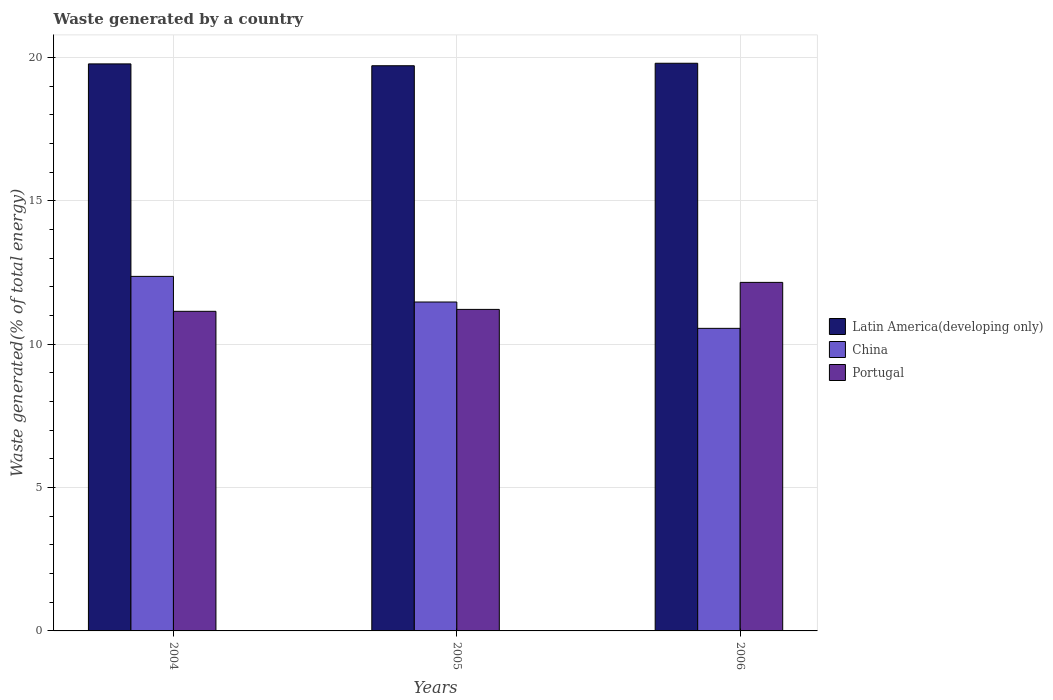Are the number of bars per tick equal to the number of legend labels?
Ensure brevity in your answer.  Yes. How many bars are there on the 2nd tick from the right?
Give a very brief answer. 3. What is the label of the 1st group of bars from the left?
Your answer should be compact. 2004. In how many cases, is the number of bars for a given year not equal to the number of legend labels?
Give a very brief answer. 0. What is the total waste generated in China in 2005?
Offer a terse response. 11.47. Across all years, what is the maximum total waste generated in Latin America(developing only)?
Ensure brevity in your answer.  19.79. Across all years, what is the minimum total waste generated in China?
Make the answer very short. 10.55. In which year was the total waste generated in Latin America(developing only) maximum?
Offer a terse response. 2006. What is the total total waste generated in Latin America(developing only) in the graph?
Provide a succinct answer. 59.28. What is the difference between the total waste generated in Portugal in 2005 and that in 2006?
Your response must be concise. -0.94. What is the difference between the total waste generated in Portugal in 2006 and the total waste generated in China in 2004?
Keep it short and to the point. -0.21. What is the average total waste generated in Portugal per year?
Your response must be concise. 11.5. In the year 2006, what is the difference between the total waste generated in Latin America(developing only) and total waste generated in Portugal?
Your answer should be very brief. 7.64. What is the ratio of the total waste generated in China in 2004 to that in 2005?
Provide a short and direct response. 1.08. Is the difference between the total waste generated in Latin America(developing only) in 2004 and 2006 greater than the difference between the total waste generated in Portugal in 2004 and 2006?
Offer a terse response. Yes. What is the difference between the highest and the second highest total waste generated in Latin America(developing only)?
Provide a succinct answer. 0.02. What is the difference between the highest and the lowest total waste generated in Portugal?
Offer a terse response. 1.01. In how many years, is the total waste generated in China greater than the average total waste generated in China taken over all years?
Provide a short and direct response. 2. Is the sum of the total waste generated in Latin America(developing only) in 2004 and 2005 greater than the maximum total waste generated in China across all years?
Offer a terse response. Yes. What does the 1st bar from the left in 2006 represents?
Your answer should be compact. Latin America(developing only). What does the 1st bar from the right in 2005 represents?
Offer a terse response. Portugal. Is it the case that in every year, the sum of the total waste generated in China and total waste generated in Portugal is greater than the total waste generated in Latin America(developing only)?
Your answer should be very brief. Yes. What is the difference between two consecutive major ticks on the Y-axis?
Make the answer very short. 5. Does the graph contain any zero values?
Provide a succinct answer. No. Does the graph contain grids?
Offer a terse response. Yes. Where does the legend appear in the graph?
Ensure brevity in your answer.  Center right. How many legend labels are there?
Keep it short and to the point. 3. How are the legend labels stacked?
Offer a terse response. Vertical. What is the title of the graph?
Provide a succinct answer. Waste generated by a country. What is the label or title of the X-axis?
Make the answer very short. Years. What is the label or title of the Y-axis?
Ensure brevity in your answer.  Waste generated(% of total energy). What is the Waste generated(% of total energy) in Latin America(developing only) in 2004?
Your response must be concise. 19.77. What is the Waste generated(% of total energy) in China in 2004?
Offer a very short reply. 12.36. What is the Waste generated(% of total energy) in Portugal in 2004?
Provide a short and direct response. 11.14. What is the Waste generated(% of total energy) of Latin America(developing only) in 2005?
Your response must be concise. 19.71. What is the Waste generated(% of total energy) of China in 2005?
Provide a succinct answer. 11.47. What is the Waste generated(% of total energy) of Portugal in 2005?
Offer a very short reply. 11.21. What is the Waste generated(% of total energy) of Latin America(developing only) in 2006?
Provide a succinct answer. 19.79. What is the Waste generated(% of total energy) in China in 2006?
Make the answer very short. 10.55. What is the Waste generated(% of total energy) in Portugal in 2006?
Keep it short and to the point. 12.15. Across all years, what is the maximum Waste generated(% of total energy) of Latin America(developing only)?
Your answer should be very brief. 19.79. Across all years, what is the maximum Waste generated(% of total energy) in China?
Offer a very short reply. 12.36. Across all years, what is the maximum Waste generated(% of total energy) of Portugal?
Provide a succinct answer. 12.15. Across all years, what is the minimum Waste generated(% of total energy) in Latin America(developing only)?
Make the answer very short. 19.71. Across all years, what is the minimum Waste generated(% of total energy) in China?
Your response must be concise. 10.55. Across all years, what is the minimum Waste generated(% of total energy) in Portugal?
Your answer should be compact. 11.14. What is the total Waste generated(% of total energy) of Latin America(developing only) in the graph?
Provide a succinct answer. 59.28. What is the total Waste generated(% of total energy) of China in the graph?
Offer a very short reply. 34.38. What is the total Waste generated(% of total energy) of Portugal in the graph?
Ensure brevity in your answer.  34.51. What is the difference between the Waste generated(% of total energy) in Latin America(developing only) in 2004 and that in 2005?
Make the answer very short. 0.06. What is the difference between the Waste generated(% of total energy) in China in 2004 and that in 2005?
Your response must be concise. 0.89. What is the difference between the Waste generated(% of total energy) in Portugal in 2004 and that in 2005?
Provide a succinct answer. -0.07. What is the difference between the Waste generated(% of total energy) of Latin America(developing only) in 2004 and that in 2006?
Offer a terse response. -0.02. What is the difference between the Waste generated(% of total energy) of China in 2004 and that in 2006?
Provide a succinct answer. 1.81. What is the difference between the Waste generated(% of total energy) in Portugal in 2004 and that in 2006?
Provide a short and direct response. -1.01. What is the difference between the Waste generated(% of total energy) of Latin America(developing only) in 2005 and that in 2006?
Provide a short and direct response. -0.09. What is the difference between the Waste generated(% of total energy) in China in 2005 and that in 2006?
Your answer should be very brief. 0.92. What is the difference between the Waste generated(% of total energy) in Portugal in 2005 and that in 2006?
Provide a succinct answer. -0.94. What is the difference between the Waste generated(% of total energy) in Latin America(developing only) in 2004 and the Waste generated(% of total energy) in China in 2005?
Offer a very short reply. 8.3. What is the difference between the Waste generated(% of total energy) in Latin America(developing only) in 2004 and the Waste generated(% of total energy) in Portugal in 2005?
Your answer should be very brief. 8.56. What is the difference between the Waste generated(% of total energy) of China in 2004 and the Waste generated(% of total energy) of Portugal in 2005?
Offer a very short reply. 1.15. What is the difference between the Waste generated(% of total energy) in Latin America(developing only) in 2004 and the Waste generated(% of total energy) in China in 2006?
Your answer should be very brief. 9.22. What is the difference between the Waste generated(% of total energy) of Latin America(developing only) in 2004 and the Waste generated(% of total energy) of Portugal in 2006?
Offer a very short reply. 7.62. What is the difference between the Waste generated(% of total energy) of China in 2004 and the Waste generated(% of total energy) of Portugal in 2006?
Your answer should be compact. 0.21. What is the difference between the Waste generated(% of total energy) in Latin America(developing only) in 2005 and the Waste generated(% of total energy) in China in 2006?
Your answer should be compact. 9.16. What is the difference between the Waste generated(% of total energy) of Latin America(developing only) in 2005 and the Waste generated(% of total energy) of Portugal in 2006?
Provide a short and direct response. 7.55. What is the difference between the Waste generated(% of total energy) in China in 2005 and the Waste generated(% of total energy) in Portugal in 2006?
Make the answer very short. -0.68. What is the average Waste generated(% of total energy) in Latin America(developing only) per year?
Offer a very short reply. 19.76. What is the average Waste generated(% of total energy) in China per year?
Keep it short and to the point. 11.46. What is the average Waste generated(% of total energy) of Portugal per year?
Give a very brief answer. 11.5. In the year 2004, what is the difference between the Waste generated(% of total energy) in Latin America(developing only) and Waste generated(% of total energy) in China?
Provide a succinct answer. 7.41. In the year 2004, what is the difference between the Waste generated(% of total energy) of Latin America(developing only) and Waste generated(% of total energy) of Portugal?
Your answer should be compact. 8.63. In the year 2004, what is the difference between the Waste generated(% of total energy) of China and Waste generated(% of total energy) of Portugal?
Give a very brief answer. 1.22. In the year 2005, what is the difference between the Waste generated(% of total energy) in Latin America(developing only) and Waste generated(% of total energy) in China?
Offer a terse response. 8.24. In the year 2005, what is the difference between the Waste generated(% of total energy) in Latin America(developing only) and Waste generated(% of total energy) in Portugal?
Offer a terse response. 8.5. In the year 2005, what is the difference between the Waste generated(% of total energy) of China and Waste generated(% of total energy) of Portugal?
Make the answer very short. 0.26. In the year 2006, what is the difference between the Waste generated(% of total energy) in Latin America(developing only) and Waste generated(% of total energy) in China?
Your response must be concise. 9.24. In the year 2006, what is the difference between the Waste generated(% of total energy) in Latin America(developing only) and Waste generated(% of total energy) in Portugal?
Offer a terse response. 7.64. In the year 2006, what is the difference between the Waste generated(% of total energy) of China and Waste generated(% of total energy) of Portugal?
Keep it short and to the point. -1.6. What is the ratio of the Waste generated(% of total energy) in Latin America(developing only) in 2004 to that in 2005?
Offer a very short reply. 1. What is the ratio of the Waste generated(% of total energy) of China in 2004 to that in 2005?
Your response must be concise. 1.08. What is the ratio of the Waste generated(% of total energy) in Portugal in 2004 to that in 2005?
Your answer should be compact. 0.99. What is the ratio of the Waste generated(% of total energy) of China in 2004 to that in 2006?
Provide a short and direct response. 1.17. What is the ratio of the Waste generated(% of total energy) in Portugal in 2004 to that in 2006?
Your answer should be compact. 0.92. What is the ratio of the Waste generated(% of total energy) of China in 2005 to that in 2006?
Offer a terse response. 1.09. What is the ratio of the Waste generated(% of total energy) of Portugal in 2005 to that in 2006?
Give a very brief answer. 0.92. What is the difference between the highest and the second highest Waste generated(% of total energy) of Latin America(developing only)?
Keep it short and to the point. 0.02. What is the difference between the highest and the second highest Waste generated(% of total energy) of China?
Provide a short and direct response. 0.89. What is the difference between the highest and the second highest Waste generated(% of total energy) of Portugal?
Ensure brevity in your answer.  0.94. What is the difference between the highest and the lowest Waste generated(% of total energy) of Latin America(developing only)?
Provide a succinct answer. 0.09. What is the difference between the highest and the lowest Waste generated(% of total energy) in China?
Your answer should be very brief. 1.81. What is the difference between the highest and the lowest Waste generated(% of total energy) of Portugal?
Give a very brief answer. 1.01. 